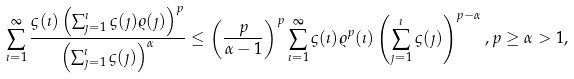Convert formula to latex. <formula><loc_0><loc_0><loc_500><loc_500>\sum _ { \imath = 1 } ^ { \infty } \frac { \varsigma ( \imath ) \left ( \sum _ { \jmath = 1 } ^ { \imath } \varsigma ( \jmath ) \varrho ( \jmath ) \right ) ^ { p } } { \left ( \sum _ { \jmath = 1 } ^ { \imath } \varsigma ( \jmath ) \right ) ^ { \alpha } } \leq \left ( \frac { p } { \alpha - 1 } \right ) ^ { p } \sum _ { \imath = 1 } ^ { \infty } \varsigma ( \imath ) \varrho ^ { p } ( \imath ) \left ( \sum _ { \jmath = 1 } ^ { \imath } \varsigma ( \jmath ) \right ) ^ { p - \alpha } , p \geq \alpha > 1 ,</formula> 